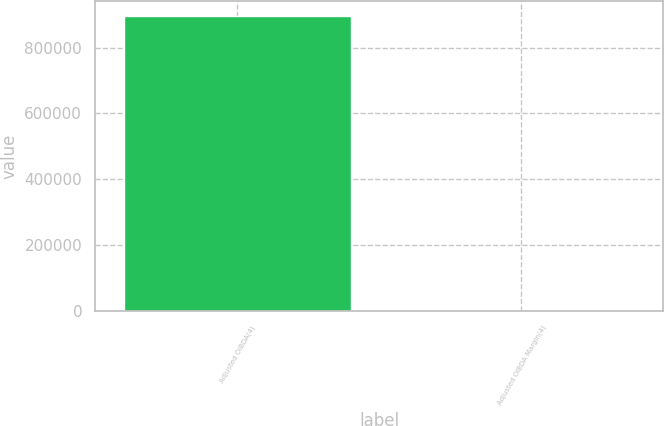Convert chart. <chart><loc_0><loc_0><loc_500><loc_500><bar_chart><fcel>Adjusted OIBDA(4)<fcel>Adjusted OIBDA Margin(4)<nl><fcel>895881<fcel>29.6<nl></chart> 